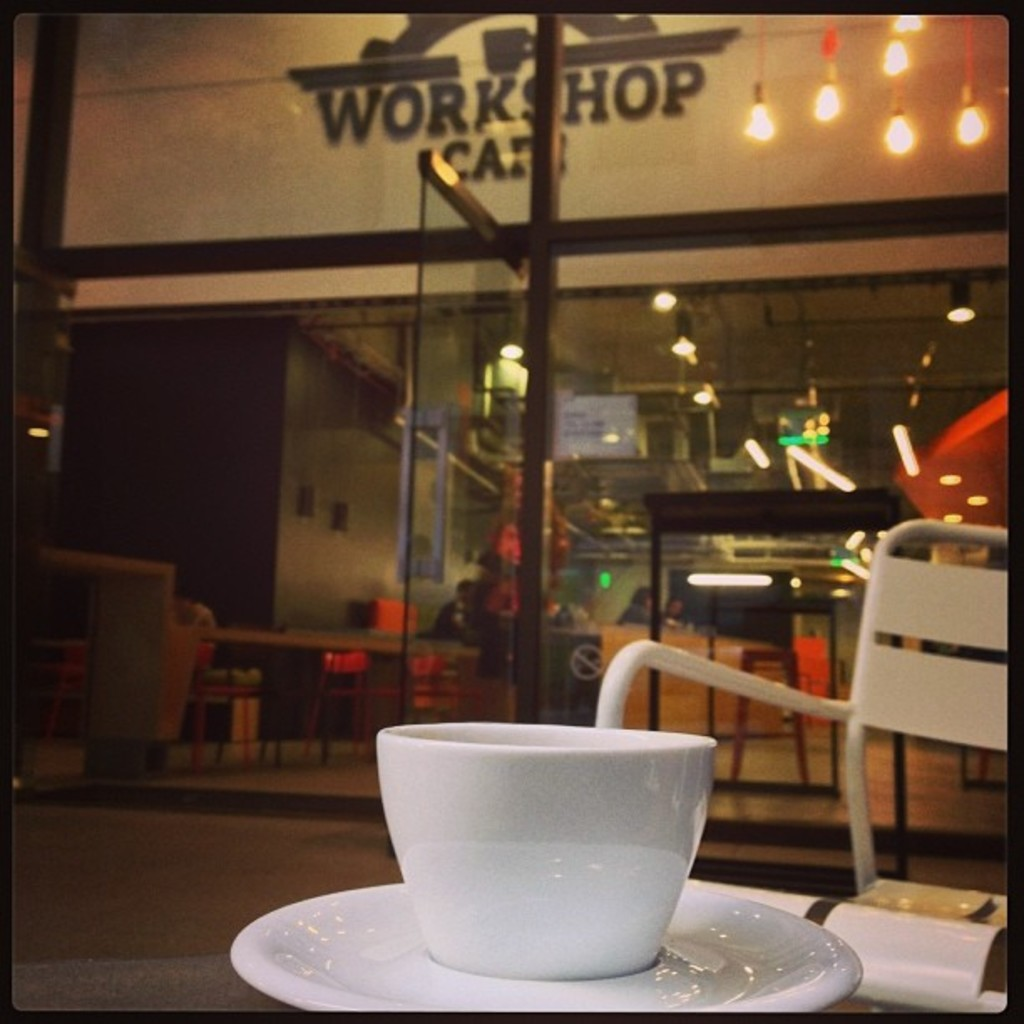How does the setting of the image contribute to the overall atmosphere captured? The setting in the 'Workshop Cafe', shown through the glass and the bustling background softened by the warm glow of hanging lights, creates a juxtaposition of energy and tranquility, encapsulating a modern urban oasis. 